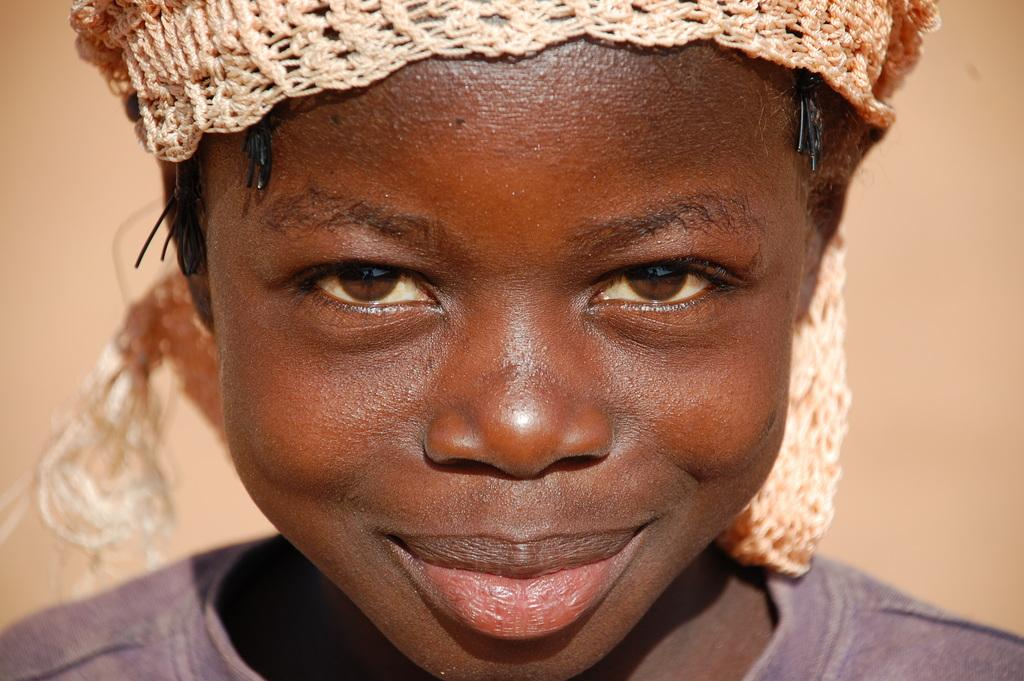Who or what is the main subject in the image? There is a person in the image. Can you describe the person's position in the image? The person is in the front. What is the person wearing on their head? The person has a cream-colored cloth on their head. How many beads are on the desk in the image? There is no desk or beads present in the image. 